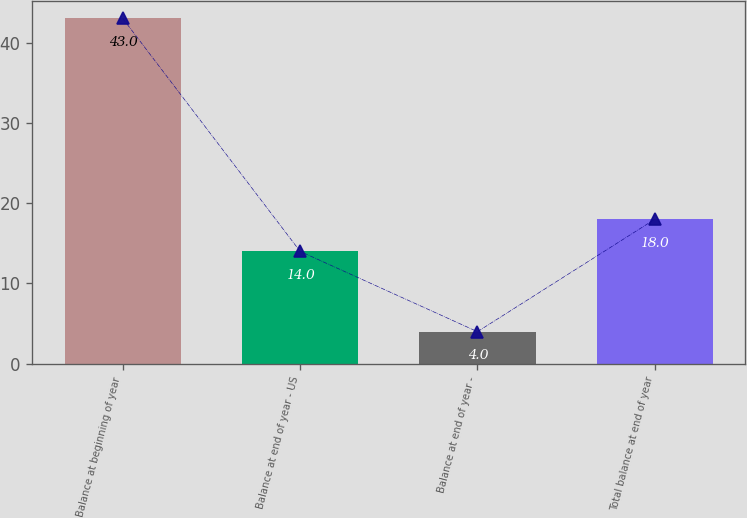<chart> <loc_0><loc_0><loc_500><loc_500><bar_chart><fcel>Balance at beginning of year<fcel>Balance at end of year - US<fcel>Balance at end of year -<fcel>Total balance at end of year<nl><fcel>43<fcel>14<fcel>4<fcel>18<nl></chart> 